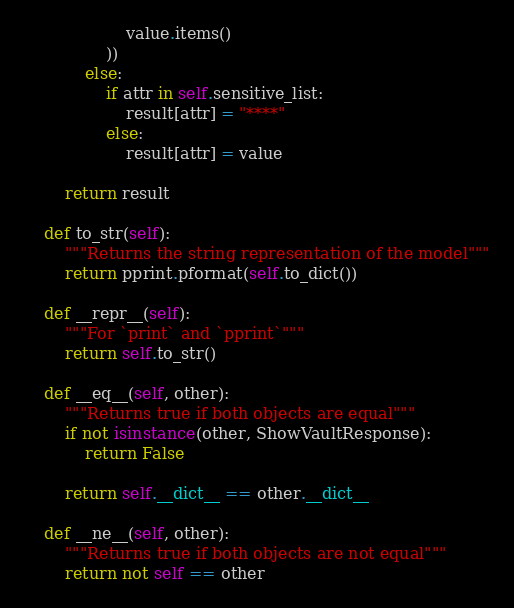Convert code to text. <code><loc_0><loc_0><loc_500><loc_500><_Python_>                    value.items()
                ))
            else:
                if attr in self.sensitive_list:
                    result[attr] = "****"
                else:
                    result[attr] = value

        return result

    def to_str(self):
        """Returns the string representation of the model"""
        return pprint.pformat(self.to_dict())

    def __repr__(self):
        """For `print` and `pprint`"""
        return self.to_str()

    def __eq__(self, other):
        """Returns true if both objects are equal"""
        if not isinstance(other, ShowVaultResponse):
            return False

        return self.__dict__ == other.__dict__

    def __ne__(self, other):
        """Returns true if both objects are not equal"""
        return not self == other
</code> 